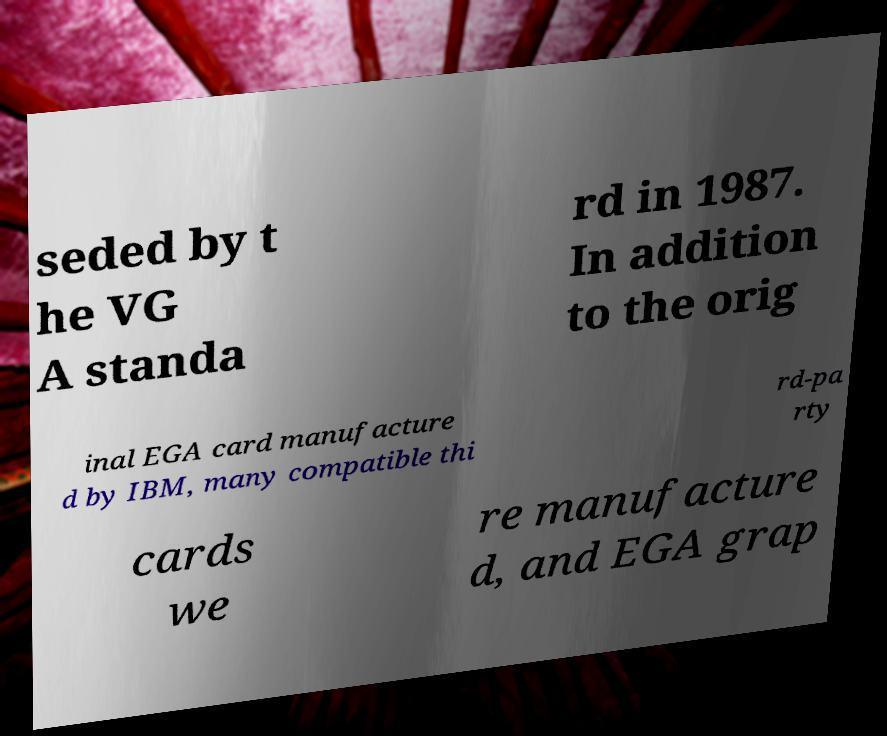I need the written content from this picture converted into text. Can you do that? seded by t he VG A standa rd in 1987. In addition to the orig inal EGA card manufacture d by IBM, many compatible thi rd-pa rty cards we re manufacture d, and EGA grap 